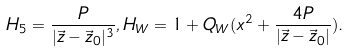<formula> <loc_0><loc_0><loc_500><loc_500>H _ { 5 } = \frac { P } { | \vec { z } - \vec { z } _ { 0 } | ^ { 3 } } , H _ { W } = 1 + Q _ { W } ( x ^ { 2 } + \frac { 4 P } { | \vec { z } - \vec { z } _ { 0 } | } ) .</formula> 